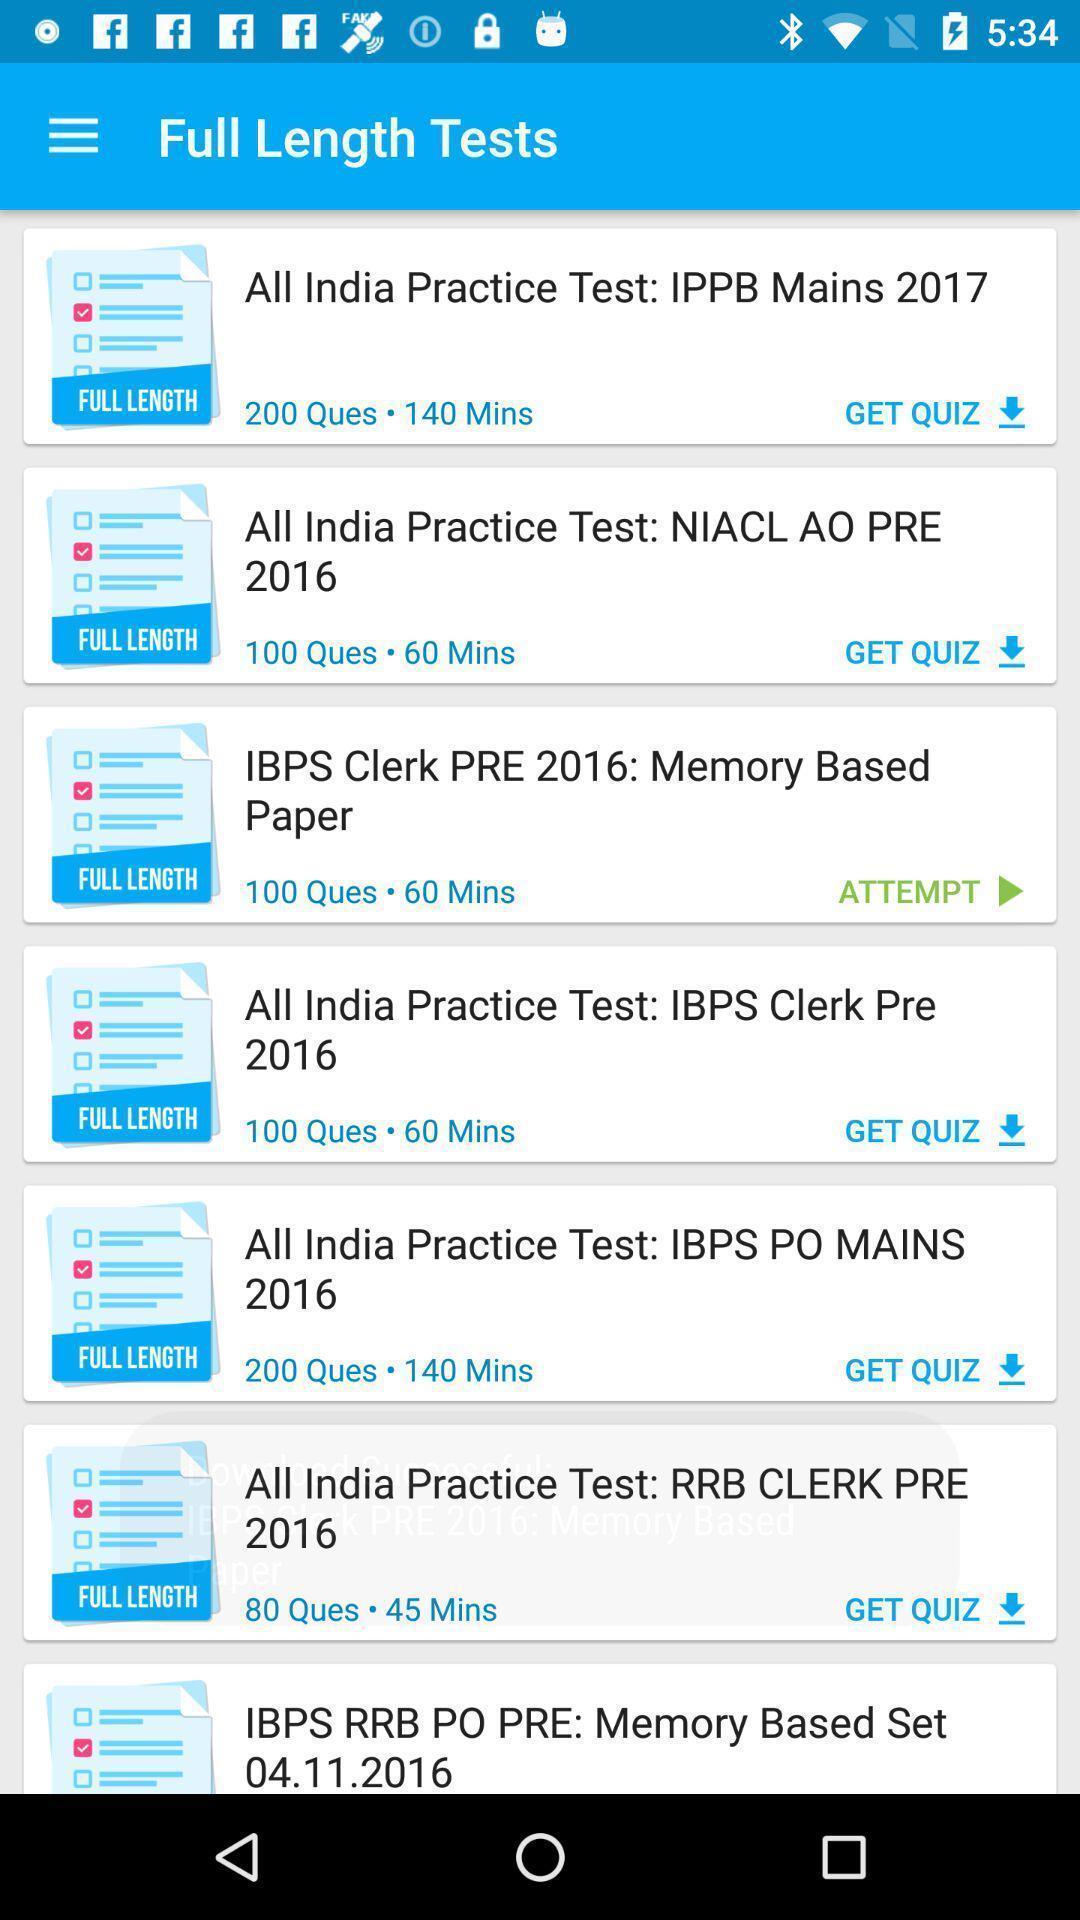Explain what's happening in this screen capture. Screen shows number of practice tests. 